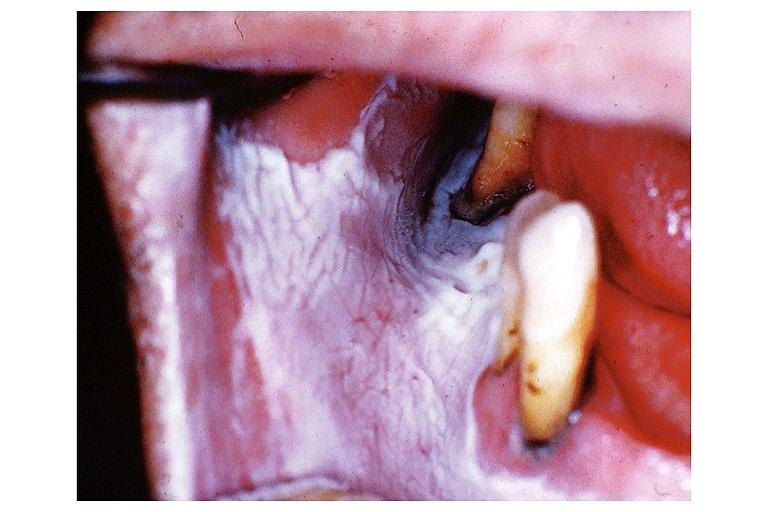what does this image show?
Answer the question using a single word or phrase. Leukoplakia 